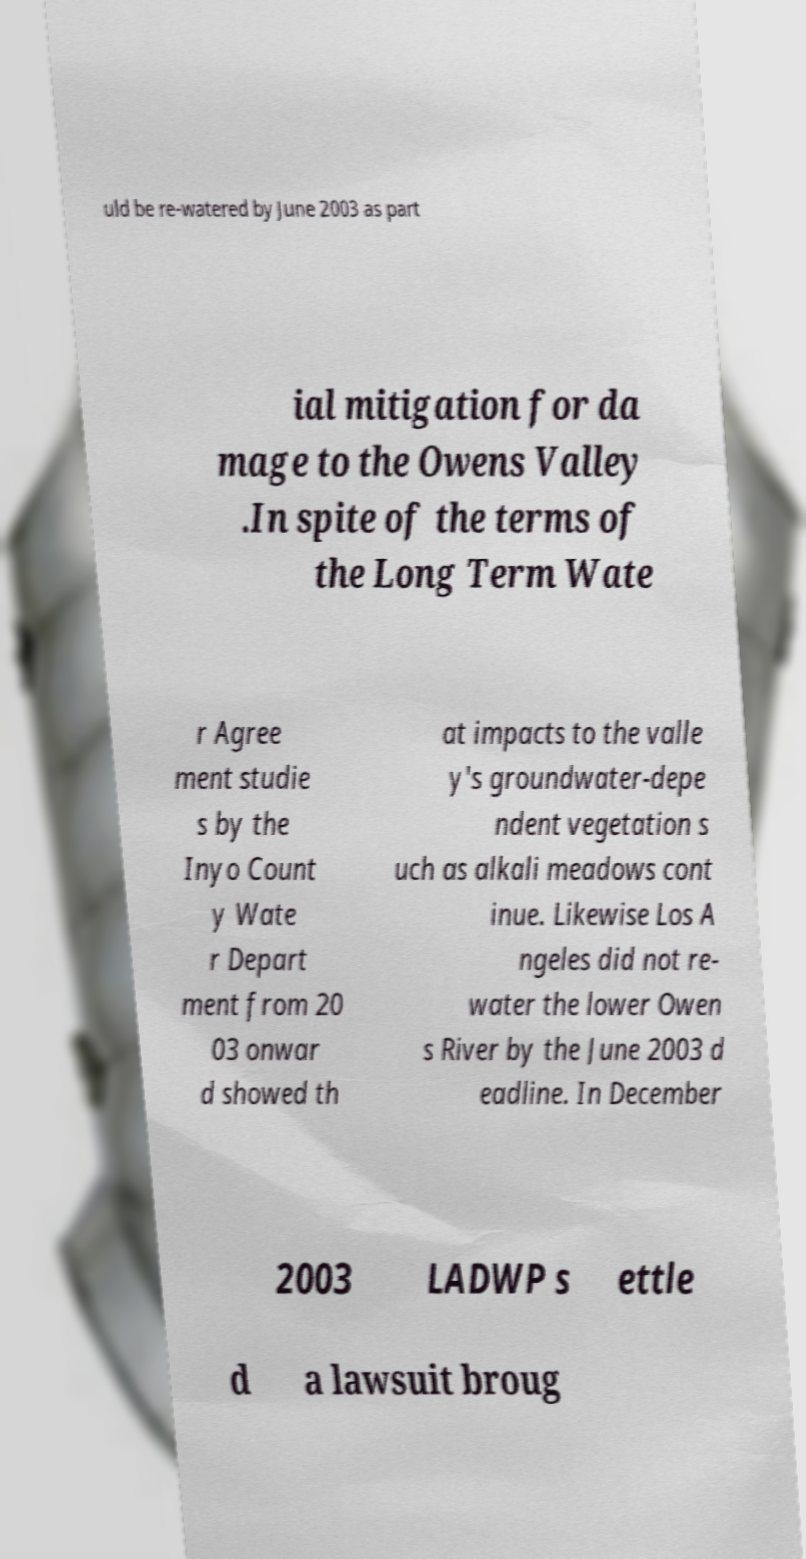What messages or text are displayed in this image? I need them in a readable, typed format. uld be re-watered by June 2003 as part ial mitigation for da mage to the Owens Valley .In spite of the terms of the Long Term Wate r Agree ment studie s by the Inyo Count y Wate r Depart ment from 20 03 onwar d showed th at impacts to the valle y's groundwater-depe ndent vegetation s uch as alkali meadows cont inue. Likewise Los A ngeles did not re- water the lower Owen s River by the June 2003 d eadline. In December 2003 LADWP s ettle d a lawsuit broug 